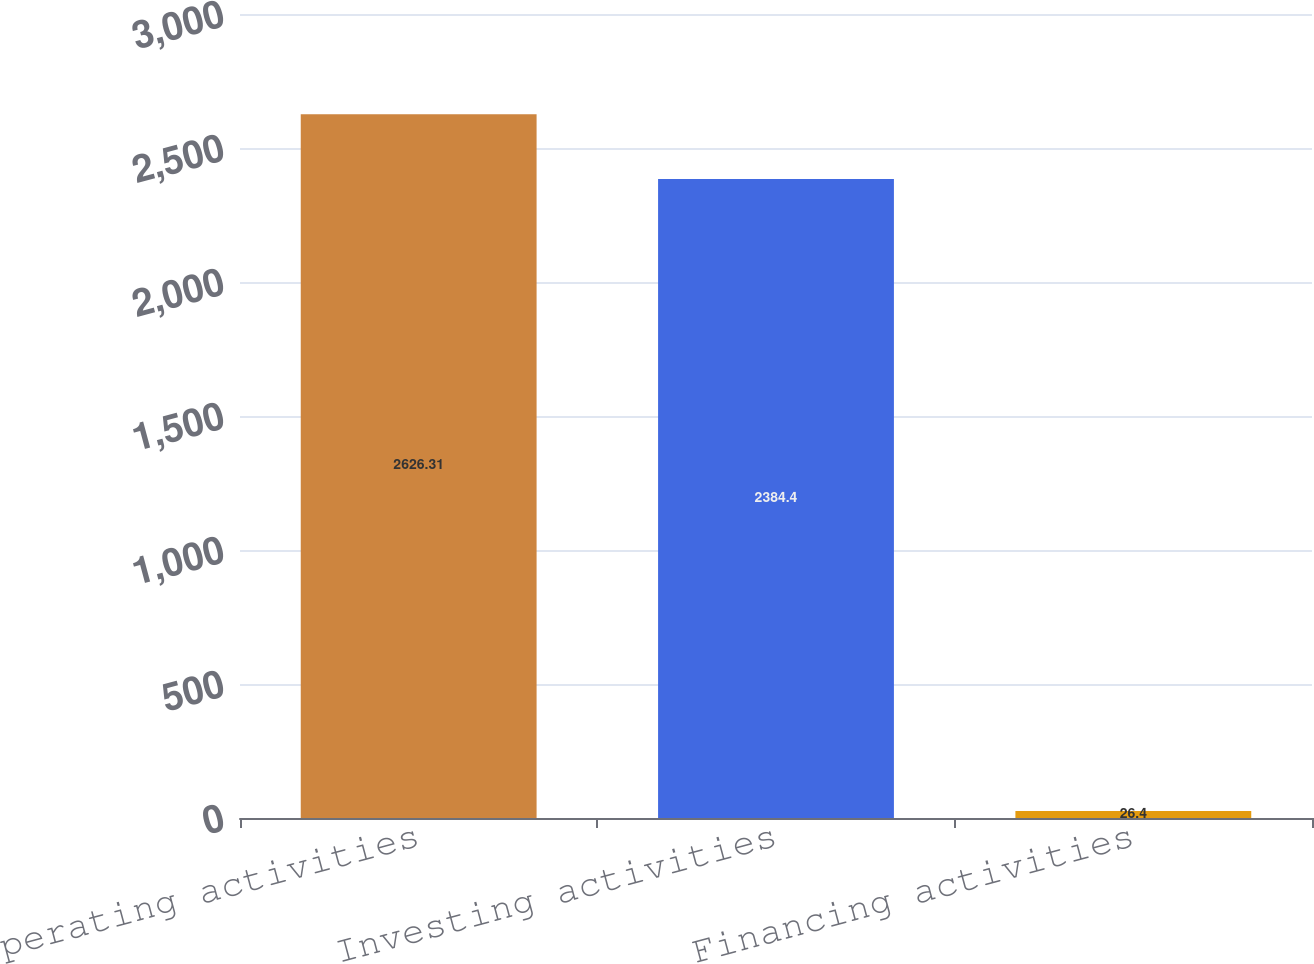Convert chart. <chart><loc_0><loc_0><loc_500><loc_500><bar_chart><fcel>Operating activities<fcel>Investing activities<fcel>Financing activities<nl><fcel>2626.31<fcel>2384.4<fcel>26.4<nl></chart> 